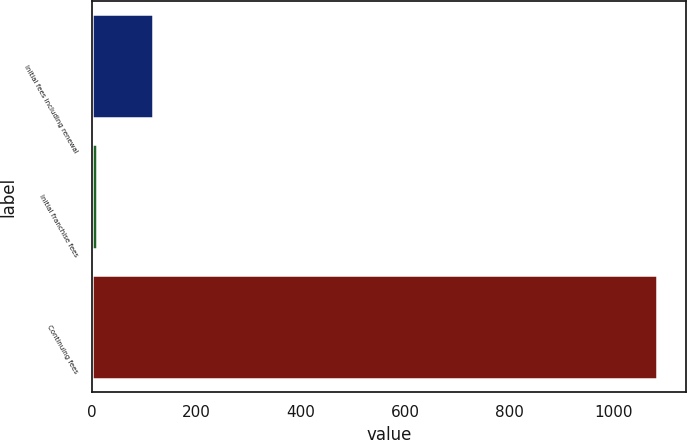<chart> <loc_0><loc_0><loc_500><loc_500><bar_chart><fcel>Initial fees including renewal<fcel>Initial franchise fees<fcel>Continuing fees<nl><fcel>117.3<fcel>10<fcel>1083<nl></chart> 